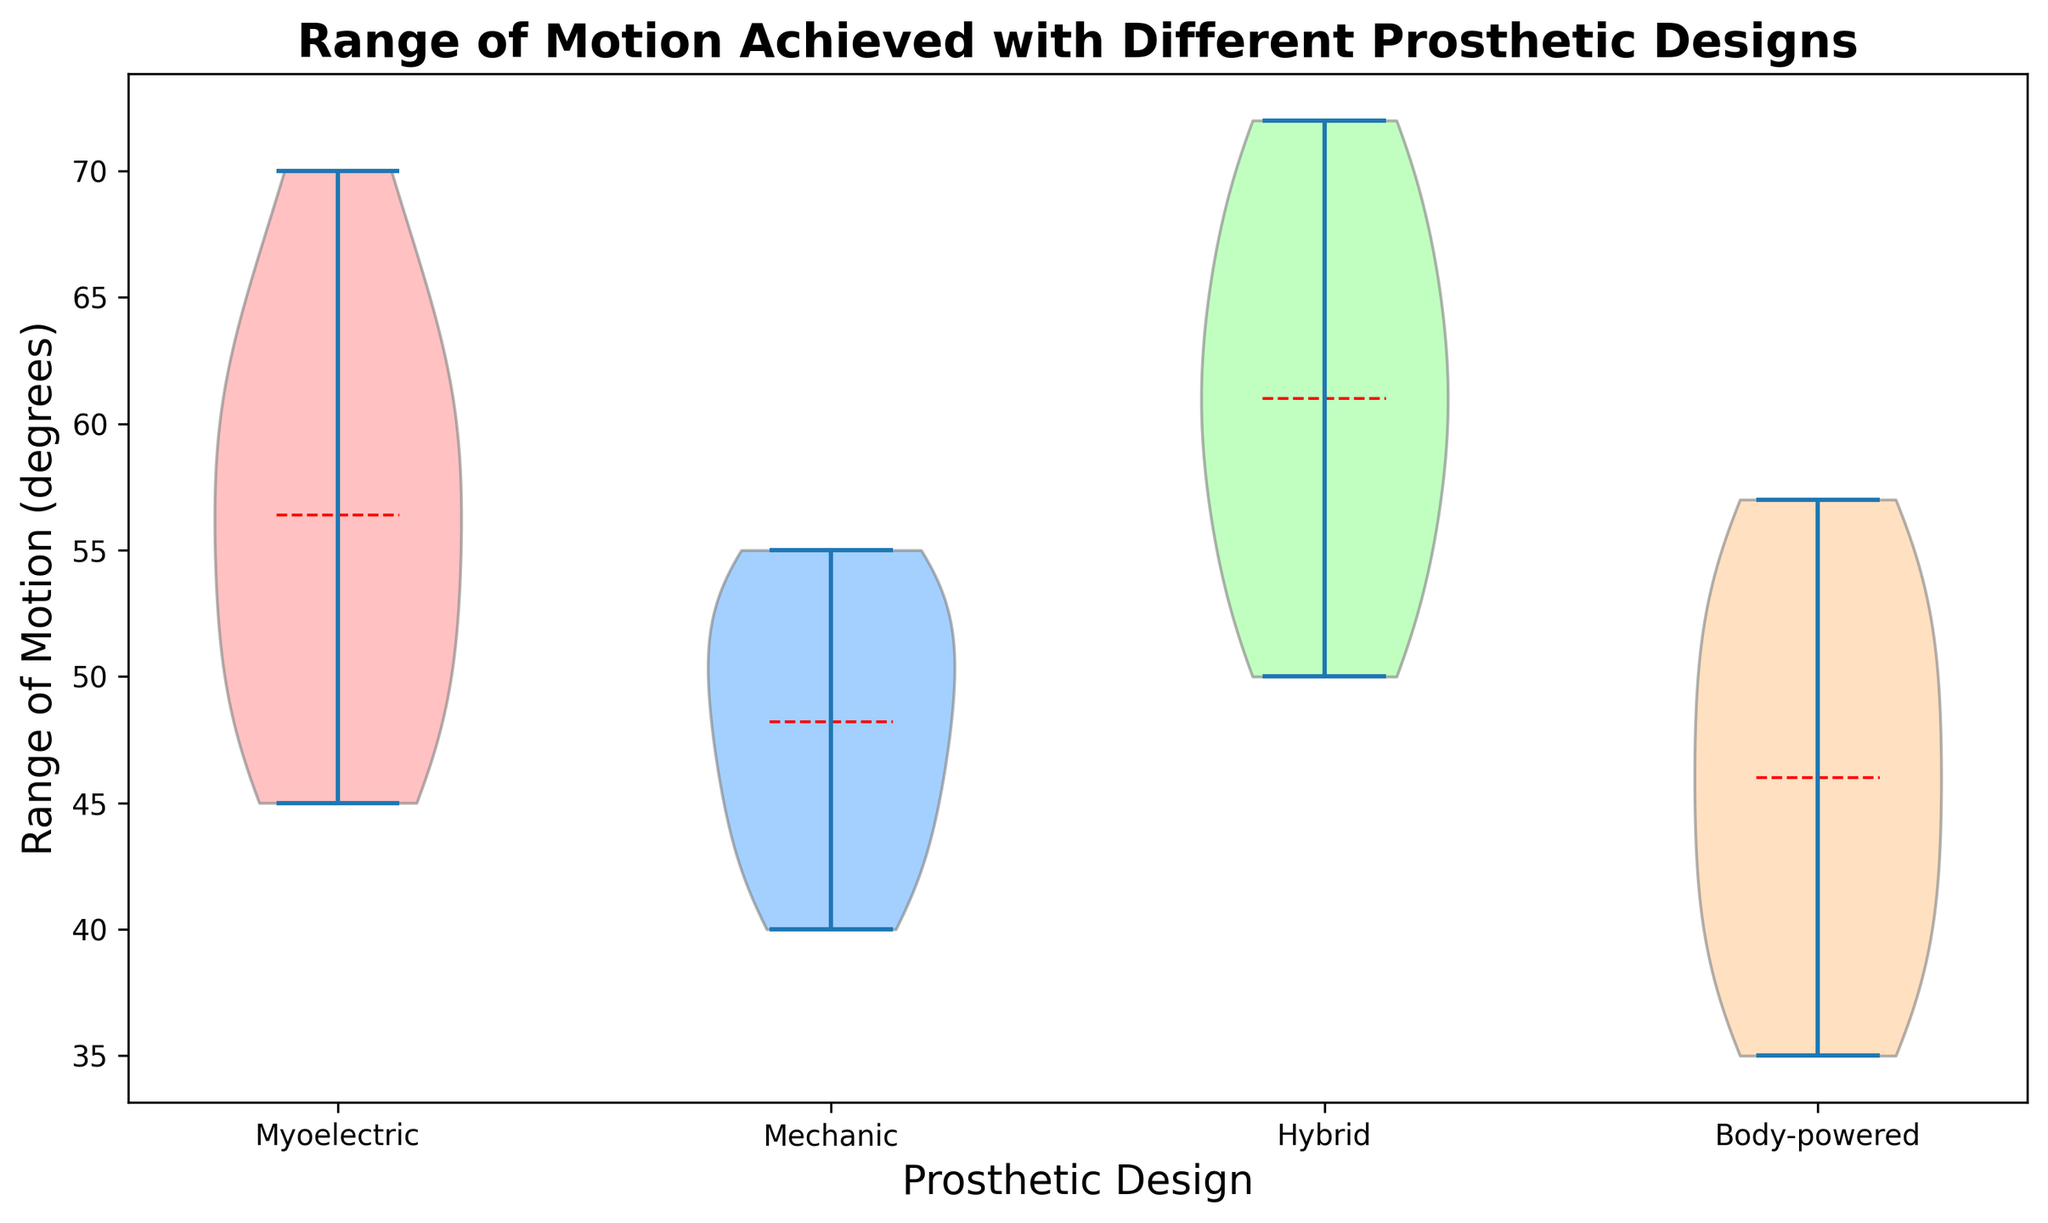How many prosthetic designs are compared in the plot? There are four unique prosthetic designs in the dataset: Myoelectric, Mechanic, Hybrid, and Body-powered. This can be seen from the x-axis labels in the violin plot.
Answer: 4 Which prosthetic design shows the highest mean range of motion? The mean is indicated by the red dashed line in each violin plot. By comparing the position of the mean lines, the Hybrid design has the highest mean range of motion.
Answer: Hybrid Which design has the widest spread of data for range of motion? The width of the violin plot at different points indicates the spread of data. The Myoelectric design has the widest spread, indicating the most variability in the range of motion achieved.
Answer: Myoelectric Compare the mean range of motion between Myoelectric and Mechanic prosthetic designs. Which one has a higher mean? The mean range of motion is shown by the red dashed line in each violin plot. The Myoelectric design has a higher mean range of motion compared to the Mechanic design.
Answer: Myoelectric Which prosthetic design has the lowest observed range of motion? The lowest data point within each violin plot indicates the minimum range of motion observed. The Body-powered design has the lowest observed range of motion at 35 degrees.
Answer: Body-powered What is the approximate range of motion for the Hybrid design? The spread of the Hybrid violin plot ranges from approximately 50 degrees to 72 degrees, covering the interquartile range of the data.
Answer: 50 to 72 degrees Do any designs exhibit any outliers in their range of motion data? Outliers are typically shown as individual points, and in this plot, no distinct points outside the violin shapes are evident, indicating no visible outliers.
Answer: No Which prosthetic design has the most compact (least variable) range of motion? The width of a violin plot indicates variability. The Mechanic design has the most compact or least variable range of motion as it has the narrowest plot.
Answer: Mechanic What can you infer about the range of motion in different prosthetic designs based on the violin plot? The violin plots show that Hybrid and Myoelectric designs generally provide a higher and more variable range of motion, Mechanic is less variable with a moderate range, while Body-powered exhibits the lowest range of motion and a moderate spread. This insight helps understand the performance and adaptability of different prosthetic designs.
Answer: Hybrid and Myoelectric have higher and more variable ranges; Mechanic is less variable; Body-powered has the lowest range 